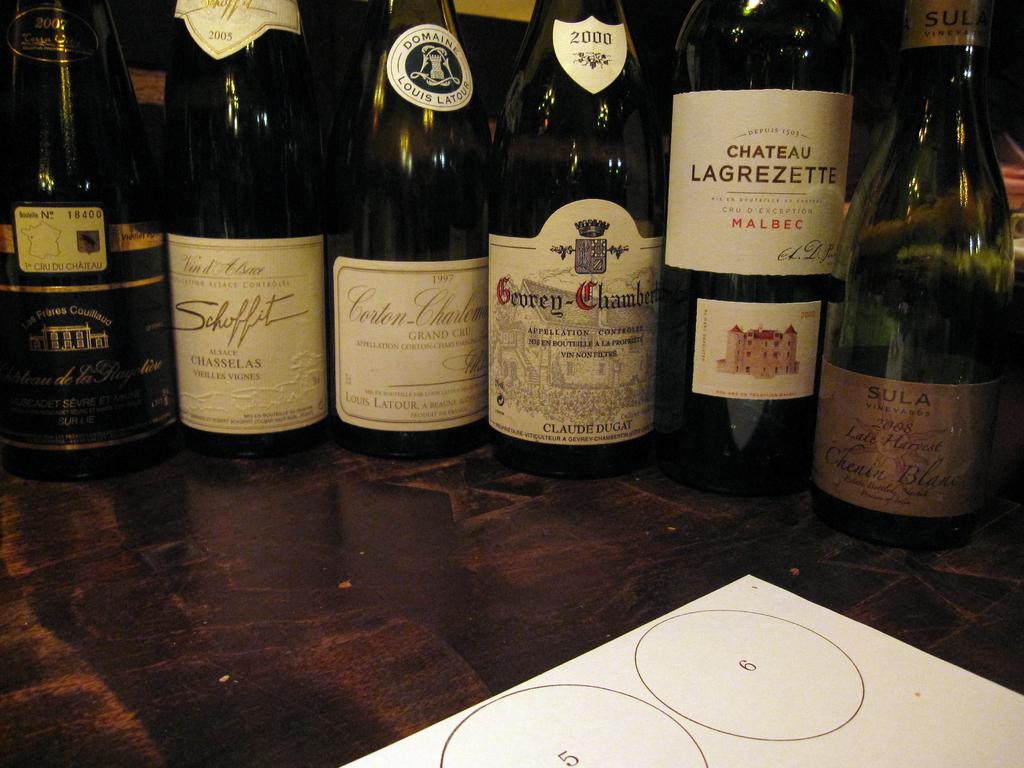What number is on the complete circle?
Your response must be concise. 6. 